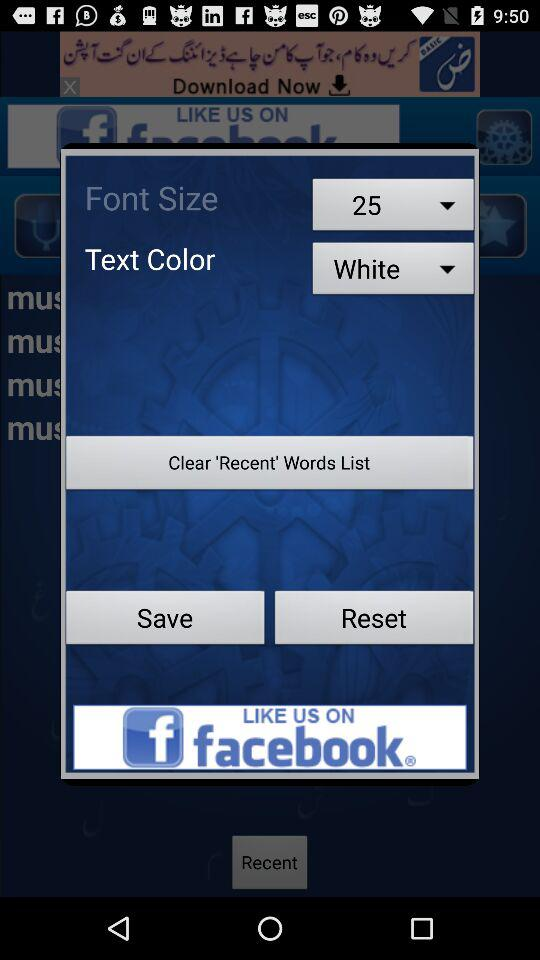What is the text color? The text color is white. 